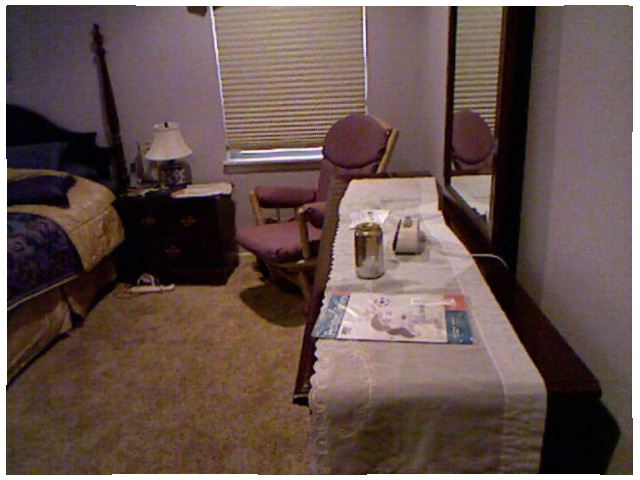<image>
Can you confirm if the unopened magazine is on the white runner? Yes. Looking at the image, I can see the unopened magazine is positioned on top of the white runner, with the white runner providing support. Is the mirror on the chair? No. The mirror is not positioned on the chair. They may be near each other, but the mirror is not supported by or resting on top of the chair. Where is the pillow in relation to the rocking chair? Is it to the left of the rocking chair? Yes. From this viewpoint, the pillow is positioned to the left side relative to the rocking chair. Is there a chair in the mirror? Yes. The chair is contained within or inside the mirror, showing a containment relationship. 